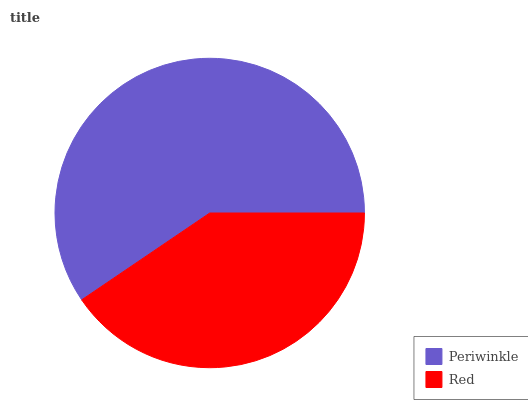Is Red the minimum?
Answer yes or no. Yes. Is Periwinkle the maximum?
Answer yes or no. Yes. Is Red the maximum?
Answer yes or no. No. Is Periwinkle greater than Red?
Answer yes or no. Yes. Is Red less than Periwinkle?
Answer yes or no. Yes. Is Red greater than Periwinkle?
Answer yes or no. No. Is Periwinkle less than Red?
Answer yes or no. No. Is Periwinkle the high median?
Answer yes or no. Yes. Is Red the low median?
Answer yes or no. Yes. Is Red the high median?
Answer yes or no. No. Is Periwinkle the low median?
Answer yes or no. No. 